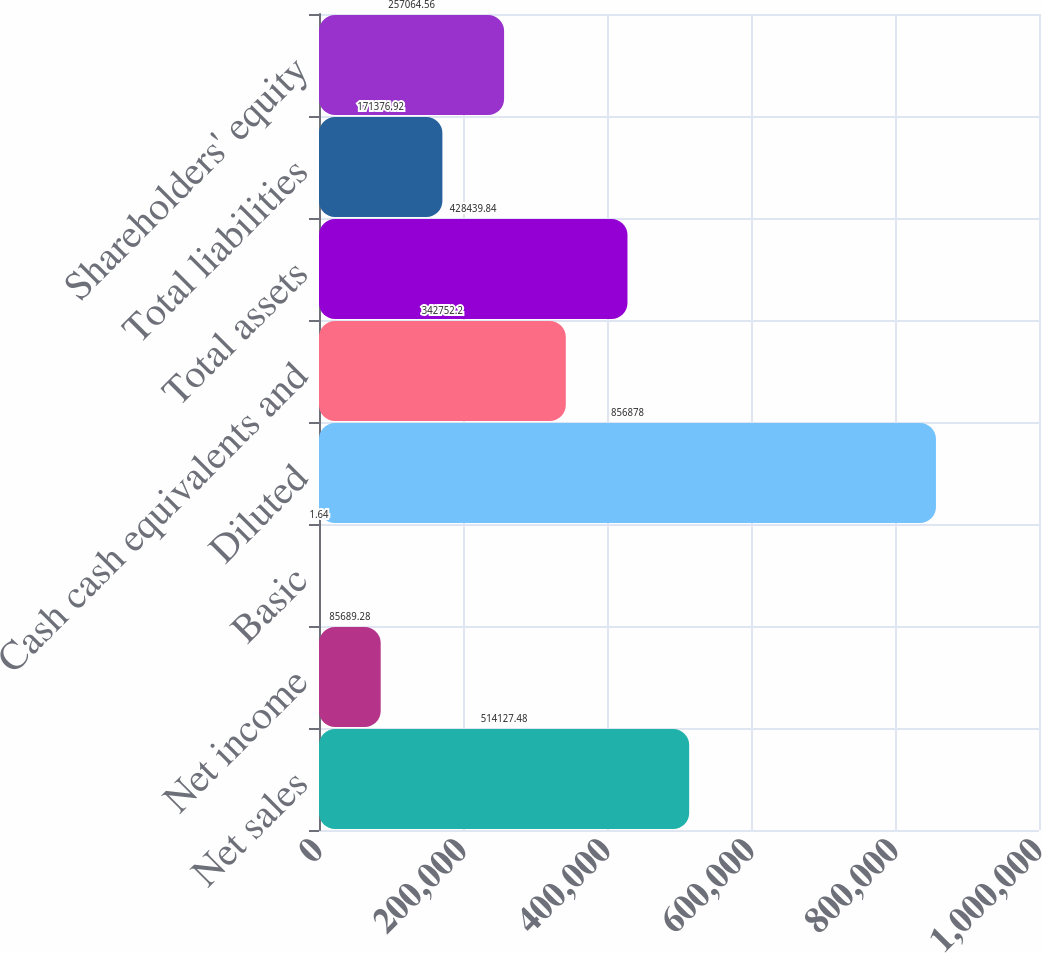<chart> <loc_0><loc_0><loc_500><loc_500><bar_chart><fcel>Net sales<fcel>Net income<fcel>Basic<fcel>Diluted<fcel>Cash cash equivalents and<fcel>Total assets<fcel>Total liabilities<fcel>Shareholders' equity<nl><fcel>514127<fcel>85689.3<fcel>1.64<fcel>856878<fcel>342752<fcel>428440<fcel>171377<fcel>257065<nl></chart> 